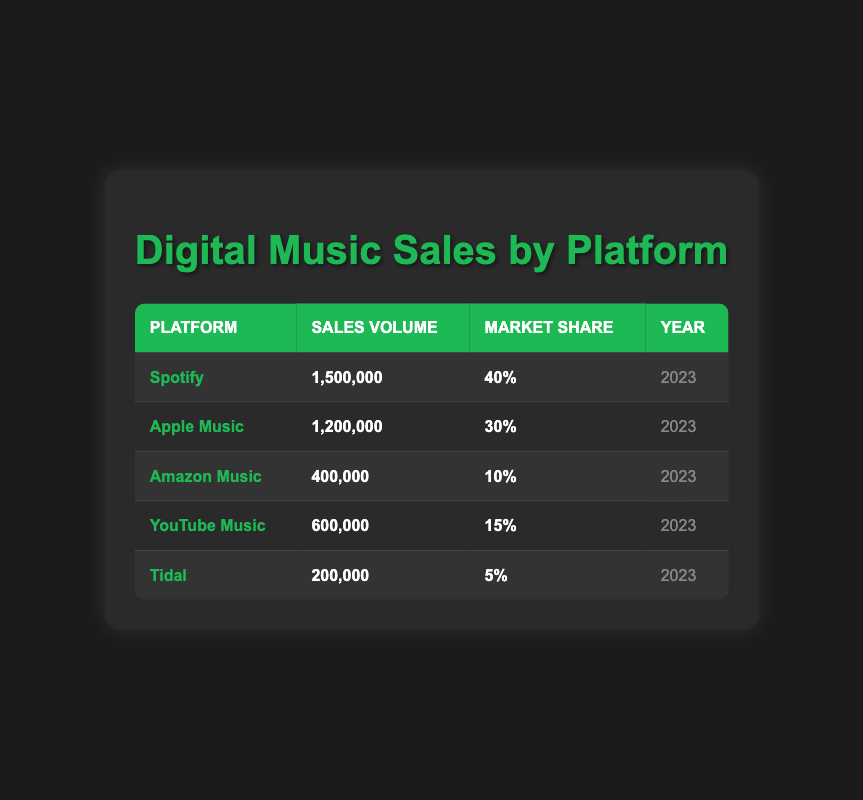What is the sales volume for Spotify? The sales volume for Spotify is listed directly in the table, which shows **1,500,000**.
Answer: 1,500,000 Which platform has the highest market share? The market shares for all platforms are listed, and the highest is **40%** for Spotify.
Answer: Spotify What is the total sales volume of Apple Music and Amazon Music combined? The sales volumes for Apple Music (1,200,000) and Amazon Music (400,000) are summed: 1,200,000 + 400,000 = 1,600,000.
Answer: 1,600,000 Is Tidal's market share greater than YouTube Music's? Tidal has a market share of **5%**, while YouTube Music has **15%**, so Tidal's market share is not greater.
Answer: No What percentage of the total market share does Amazon Music hold compared to the total market share of Spotify and Apple Music? First, calculate the total market share for Spotify and Apple Music: 40% + 30% = 70%. Amazon Music's market share is **10%**. Then, 10% compared to 70% is given by: (10/70) * 100 = 14.29%.
Answer: 14.29% What is the difference in sales volume between the highest and lowest platforms? The highest sales volume is from Spotify at **1,500,000**, and the lowest is Tidal at **200,000**. The difference is calculated as: 1,500,000 - 200,000 = 1,300,000.
Answer: 1,300,000 Are there more platforms with sales volumes above or below 500,000? The platforms with sales above 500,000 are Spotify and Apple Music, which counts as 2. Platforms below 500,000 are Amazon Music, YouTube Music, and Tidal, which count as 3. Hence, there are more below.
Answer: Below 500,000 What is the average sales volume of all the platforms? First, calculate the total sales volume: 1,500,000 + 1,200,000 + 400,000 + 600,000 + 200,000 = 3,900,000. Then, divide by the number of platforms (5): 3,900,000 / 5 = 780,000.
Answer: 780,000 